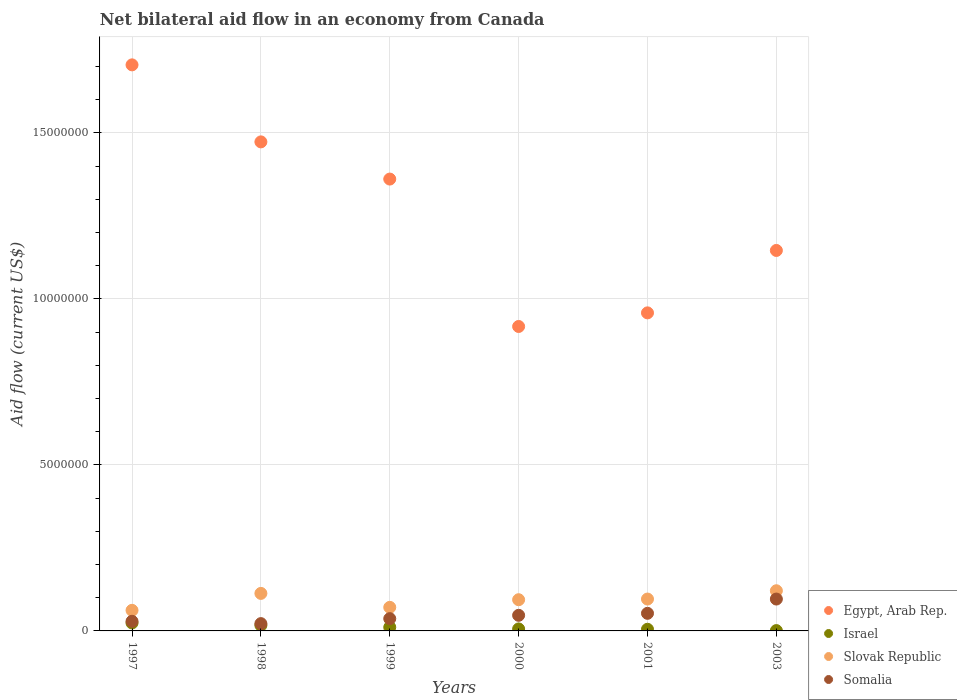Is the number of dotlines equal to the number of legend labels?
Ensure brevity in your answer.  Yes. What is the net bilateral aid flow in Somalia in 1998?
Offer a terse response. 2.20e+05. Across all years, what is the maximum net bilateral aid flow in Egypt, Arab Rep.?
Your response must be concise. 1.70e+07. Across all years, what is the minimum net bilateral aid flow in Egypt, Arab Rep.?
Make the answer very short. 9.17e+06. In which year was the net bilateral aid flow in Slovak Republic minimum?
Provide a succinct answer. 1997. What is the total net bilateral aid flow in Slovak Republic in the graph?
Provide a succinct answer. 5.57e+06. What is the difference between the net bilateral aid flow in Somalia in 1998 and that in 2003?
Provide a short and direct response. -7.40e+05. What is the difference between the net bilateral aid flow in Israel in 1998 and the net bilateral aid flow in Somalia in 1997?
Provide a succinct answer. -1.20e+05. What is the average net bilateral aid flow in Egypt, Arab Rep. per year?
Your answer should be very brief. 1.26e+07. In how many years, is the net bilateral aid flow in Egypt, Arab Rep. greater than 6000000 US$?
Offer a terse response. 6. What is the ratio of the net bilateral aid flow in Slovak Republic in 1997 to that in 2001?
Make the answer very short. 0.65. What is the difference between the highest and the lowest net bilateral aid flow in Egypt, Arab Rep.?
Your answer should be very brief. 7.88e+06. In how many years, is the net bilateral aid flow in Egypt, Arab Rep. greater than the average net bilateral aid flow in Egypt, Arab Rep. taken over all years?
Ensure brevity in your answer.  3. Is it the case that in every year, the sum of the net bilateral aid flow in Egypt, Arab Rep. and net bilateral aid flow in Somalia  is greater than the sum of net bilateral aid flow in Israel and net bilateral aid flow in Slovak Republic?
Offer a very short reply. Yes. Is it the case that in every year, the sum of the net bilateral aid flow in Slovak Republic and net bilateral aid flow in Somalia  is greater than the net bilateral aid flow in Israel?
Ensure brevity in your answer.  Yes. Does the net bilateral aid flow in Somalia monotonically increase over the years?
Make the answer very short. No. Is the net bilateral aid flow in Slovak Republic strictly greater than the net bilateral aid flow in Egypt, Arab Rep. over the years?
Provide a succinct answer. No. Are the values on the major ticks of Y-axis written in scientific E-notation?
Your answer should be very brief. No. Does the graph contain any zero values?
Provide a succinct answer. No. Does the graph contain grids?
Offer a very short reply. Yes. Where does the legend appear in the graph?
Offer a terse response. Bottom right. What is the title of the graph?
Provide a short and direct response. Net bilateral aid flow in an economy from Canada. Does "Macedonia" appear as one of the legend labels in the graph?
Your response must be concise. No. What is the label or title of the X-axis?
Offer a very short reply. Years. What is the Aid flow (current US$) of Egypt, Arab Rep. in 1997?
Give a very brief answer. 1.70e+07. What is the Aid flow (current US$) in Israel in 1997?
Keep it short and to the point. 2.40e+05. What is the Aid flow (current US$) of Slovak Republic in 1997?
Give a very brief answer. 6.20e+05. What is the Aid flow (current US$) in Somalia in 1997?
Ensure brevity in your answer.  2.90e+05. What is the Aid flow (current US$) in Egypt, Arab Rep. in 1998?
Provide a short and direct response. 1.47e+07. What is the Aid flow (current US$) in Slovak Republic in 1998?
Provide a short and direct response. 1.13e+06. What is the Aid flow (current US$) in Somalia in 1998?
Offer a terse response. 2.20e+05. What is the Aid flow (current US$) in Egypt, Arab Rep. in 1999?
Your answer should be very brief. 1.36e+07. What is the Aid flow (current US$) of Israel in 1999?
Provide a short and direct response. 1.10e+05. What is the Aid flow (current US$) of Slovak Republic in 1999?
Your answer should be compact. 7.10e+05. What is the Aid flow (current US$) of Egypt, Arab Rep. in 2000?
Keep it short and to the point. 9.17e+06. What is the Aid flow (current US$) in Israel in 2000?
Your answer should be very brief. 6.00e+04. What is the Aid flow (current US$) of Slovak Republic in 2000?
Provide a succinct answer. 9.40e+05. What is the Aid flow (current US$) of Egypt, Arab Rep. in 2001?
Provide a short and direct response. 9.58e+06. What is the Aid flow (current US$) of Israel in 2001?
Provide a succinct answer. 5.00e+04. What is the Aid flow (current US$) in Slovak Republic in 2001?
Give a very brief answer. 9.60e+05. What is the Aid flow (current US$) in Somalia in 2001?
Your answer should be very brief. 5.30e+05. What is the Aid flow (current US$) in Egypt, Arab Rep. in 2003?
Provide a succinct answer. 1.15e+07. What is the Aid flow (current US$) in Slovak Republic in 2003?
Provide a succinct answer. 1.21e+06. What is the Aid flow (current US$) of Somalia in 2003?
Keep it short and to the point. 9.60e+05. Across all years, what is the maximum Aid flow (current US$) of Egypt, Arab Rep.?
Keep it short and to the point. 1.70e+07. Across all years, what is the maximum Aid flow (current US$) of Slovak Republic?
Give a very brief answer. 1.21e+06. Across all years, what is the maximum Aid flow (current US$) in Somalia?
Give a very brief answer. 9.60e+05. Across all years, what is the minimum Aid flow (current US$) in Egypt, Arab Rep.?
Provide a succinct answer. 9.17e+06. Across all years, what is the minimum Aid flow (current US$) in Israel?
Your answer should be very brief. 10000. Across all years, what is the minimum Aid flow (current US$) in Slovak Republic?
Provide a succinct answer. 6.20e+05. Across all years, what is the minimum Aid flow (current US$) of Somalia?
Offer a terse response. 2.20e+05. What is the total Aid flow (current US$) of Egypt, Arab Rep. in the graph?
Give a very brief answer. 7.56e+07. What is the total Aid flow (current US$) of Israel in the graph?
Your answer should be compact. 6.40e+05. What is the total Aid flow (current US$) in Slovak Republic in the graph?
Ensure brevity in your answer.  5.57e+06. What is the total Aid flow (current US$) of Somalia in the graph?
Ensure brevity in your answer.  2.84e+06. What is the difference between the Aid flow (current US$) of Egypt, Arab Rep. in 1997 and that in 1998?
Your response must be concise. 2.32e+06. What is the difference between the Aid flow (current US$) in Slovak Republic in 1997 and that in 1998?
Keep it short and to the point. -5.10e+05. What is the difference between the Aid flow (current US$) in Egypt, Arab Rep. in 1997 and that in 1999?
Provide a short and direct response. 3.44e+06. What is the difference between the Aid flow (current US$) of Israel in 1997 and that in 1999?
Provide a succinct answer. 1.30e+05. What is the difference between the Aid flow (current US$) of Somalia in 1997 and that in 1999?
Make the answer very short. -8.00e+04. What is the difference between the Aid flow (current US$) of Egypt, Arab Rep. in 1997 and that in 2000?
Provide a short and direct response. 7.88e+06. What is the difference between the Aid flow (current US$) in Slovak Republic in 1997 and that in 2000?
Keep it short and to the point. -3.20e+05. What is the difference between the Aid flow (current US$) of Somalia in 1997 and that in 2000?
Keep it short and to the point. -1.80e+05. What is the difference between the Aid flow (current US$) in Egypt, Arab Rep. in 1997 and that in 2001?
Provide a short and direct response. 7.47e+06. What is the difference between the Aid flow (current US$) of Israel in 1997 and that in 2001?
Offer a very short reply. 1.90e+05. What is the difference between the Aid flow (current US$) in Somalia in 1997 and that in 2001?
Your response must be concise. -2.40e+05. What is the difference between the Aid flow (current US$) of Egypt, Arab Rep. in 1997 and that in 2003?
Make the answer very short. 5.59e+06. What is the difference between the Aid flow (current US$) in Israel in 1997 and that in 2003?
Provide a short and direct response. 2.30e+05. What is the difference between the Aid flow (current US$) in Slovak Republic in 1997 and that in 2003?
Your answer should be compact. -5.90e+05. What is the difference between the Aid flow (current US$) in Somalia in 1997 and that in 2003?
Offer a very short reply. -6.70e+05. What is the difference between the Aid flow (current US$) in Egypt, Arab Rep. in 1998 and that in 1999?
Your answer should be very brief. 1.12e+06. What is the difference between the Aid flow (current US$) in Egypt, Arab Rep. in 1998 and that in 2000?
Give a very brief answer. 5.56e+06. What is the difference between the Aid flow (current US$) of Egypt, Arab Rep. in 1998 and that in 2001?
Provide a succinct answer. 5.15e+06. What is the difference between the Aid flow (current US$) in Israel in 1998 and that in 2001?
Your response must be concise. 1.20e+05. What is the difference between the Aid flow (current US$) in Slovak Republic in 1998 and that in 2001?
Ensure brevity in your answer.  1.70e+05. What is the difference between the Aid flow (current US$) of Somalia in 1998 and that in 2001?
Ensure brevity in your answer.  -3.10e+05. What is the difference between the Aid flow (current US$) in Egypt, Arab Rep. in 1998 and that in 2003?
Offer a very short reply. 3.27e+06. What is the difference between the Aid flow (current US$) of Israel in 1998 and that in 2003?
Your answer should be compact. 1.60e+05. What is the difference between the Aid flow (current US$) of Slovak Republic in 1998 and that in 2003?
Provide a succinct answer. -8.00e+04. What is the difference between the Aid flow (current US$) in Somalia in 1998 and that in 2003?
Your answer should be very brief. -7.40e+05. What is the difference between the Aid flow (current US$) of Egypt, Arab Rep. in 1999 and that in 2000?
Make the answer very short. 4.44e+06. What is the difference between the Aid flow (current US$) of Israel in 1999 and that in 2000?
Keep it short and to the point. 5.00e+04. What is the difference between the Aid flow (current US$) of Slovak Republic in 1999 and that in 2000?
Offer a very short reply. -2.30e+05. What is the difference between the Aid flow (current US$) of Egypt, Arab Rep. in 1999 and that in 2001?
Keep it short and to the point. 4.03e+06. What is the difference between the Aid flow (current US$) in Egypt, Arab Rep. in 1999 and that in 2003?
Your answer should be compact. 2.15e+06. What is the difference between the Aid flow (current US$) in Slovak Republic in 1999 and that in 2003?
Keep it short and to the point. -5.00e+05. What is the difference between the Aid flow (current US$) of Somalia in 1999 and that in 2003?
Your answer should be very brief. -5.90e+05. What is the difference between the Aid flow (current US$) of Egypt, Arab Rep. in 2000 and that in 2001?
Keep it short and to the point. -4.10e+05. What is the difference between the Aid flow (current US$) in Slovak Republic in 2000 and that in 2001?
Your answer should be compact. -2.00e+04. What is the difference between the Aid flow (current US$) in Somalia in 2000 and that in 2001?
Provide a short and direct response. -6.00e+04. What is the difference between the Aid flow (current US$) of Egypt, Arab Rep. in 2000 and that in 2003?
Your response must be concise. -2.29e+06. What is the difference between the Aid flow (current US$) of Israel in 2000 and that in 2003?
Ensure brevity in your answer.  5.00e+04. What is the difference between the Aid flow (current US$) in Somalia in 2000 and that in 2003?
Ensure brevity in your answer.  -4.90e+05. What is the difference between the Aid flow (current US$) in Egypt, Arab Rep. in 2001 and that in 2003?
Make the answer very short. -1.88e+06. What is the difference between the Aid flow (current US$) of Somalia in 2001 and that in 2003?
Provide a short and direct response. -4.30e+05. What is the difference between the Aid flow (current US$) of Egypt, Arab Rep. in 1997 and the Aid flow (current US$) of Israel in 1998?
Keep it short and to the point. 1.69e+07. What is the difference between the Aid flow (current US$) of Egypt, Arab Rep. in 1997 and the Aid flow (current US$) of Slovak Republic in 1998?
Offer a terse response. 1.59e+07. What is the difference between the Aid flow (current US$) in Egypt, Arab Rep. in 1997 and the Aid flow (current US$) in Somalia in 1998?
Provide a short and direct response. 1.68e+07. What is the difference between the Aid flow (current US$) of Israel in 1997 and the Aid flow (current US$) of Slovak Republic in 1998?
Provide a short and direct response. -8.90e+05. What is the difference between the Aid flow (current US$) in Egypt, Arab Rep. in 1997 and the Aid flow (current US$) in Israel in 1999?
Ensure brevity in your answer.  1.69e+07. What is the difference between the Aid flow (current US$) in Egypt, Arab Rep. in 1997 and the Aid flow (current US$) in Slovak Republic in 1999?
Make the answer very short. 1.63e+07. What is the difference between the Aid flow (current US$) in Egypt, Arab Rep. in 1997 and the Aid flow (current US$) in Somalia in 1999?
Ensure brevity in your answer.  1.67e+07. What is the difference between the Aid flow (current US$) of Israel in 1997 and the Aid flow (current US$) of Slovak Republic in 1999?
Give a very brief answer. -4.70e+05. What is the difference between the Aid flow (current US$) of Israel in 1997 and the Aid flow (current US$) of Somalia in 1999?
Provide a succinct answer. -1.30e+05. What is the difference between the Aid flow (current US$) in Slovak Republic in 1997 and the Aid flow (current US$) in Somalia in 1999?
Provide a succinct answer. 2.50e+05. What is the difference between the Aid flow (current US$) of Egypt, Arab Rep. in 1997 and the Aid flow (current US$) of Israel in 2000?
Your response must be concise. 1.70e+07. What is the difference between the Aid flow (current US$) of Egypt, Arab Rep. in 1997 and the Aid flow (current US$) of Slovak Republic in 2000?
Your answer should be compact. 1.61e+07. What is the difference between the Aid flow (current US$) of Egypt, Arab Rep. in 1997 and the Aid flow (current US$) of Somalia in 2000?
Keep it short and to the point. 1.66e+07. What is the difference between the Aid flow (current US$) of Israel in 1997 and the Aid flow (current US$) of Slovak Republic in 2000?
Provide a succinct answer. -7.00e+05. What is the difference between the Aid flow (current US$) in Egypt, Arab Rep. in 1997 and the Aid flow (current US$) in Israel in 2001?
Offer a very short reply. 1.70e+07. What is the difference between the Aid flow (current US$) of Egypt, Arab Rep. in 1997 and the Aid flow (current US$) of Slovak Republic in 2001?
Provide a short and direct response. 1.61e+07. What is the difference between the Aid flow (current US$) in Egypt, Arab Rep. in 1997 and the Aid flow (current US$) in Somalia in 2001?
Make the answer very short. 1.65e+07. What is the difference between the Aid flow (current US$) in Israel in 1997 and the Aid flow (current US$) in Slovak Republic in 2001?
Your response must be concise. -7.20e+05. What is the difference between the Aid flow (current US$) of Egypt, Arab Rep. in 1997 and the Aid flow (current US$) of Israel in 2003?
Offer a very short reply. 1.70e+07. What is the difference between the Aid flow (current US$) in Egypt, Arab Rep. in 1997 and the Aid flow (current US$) in Slovak Republic in 2003?
Offer a very short reply. 1.58e+07. What is the difference between the Aid flow (current US$) of Egypt, Arab Rep. in 1997 and the Aid flow (current US$) of Somalia in 2003?
Provide a succinct answer. 1.61e+07. What is the difference between the Aid flow (current US$) of Israel in 1997 and the Aid flow (current US$) of Slovak Republic in 2003?
Provide a short and direct response. -9.70e+05. What is the difference between the Aid flow (current US$) of Israel in 1997 and the Aid flow (current US$) of Somalia in 2003?
Provide a succinct answer. -7.20e+05. What is the difference between the Aid flow (current US$) in Slovak Republic in 1997 and the Aid flow (current US$) in Somalia in 2003?
Offer a very short reply. -3.40e+05. What is the difference between the Aid flow (current US$) in Egypt, Arab Rep. in 1998 and the Aid flow (current US$) in Israel in 1999?
Your answer should be compact. 1.46e+07. What is the difference between the Aid flow (current US$) in Egypt, Arab Rep. in 1998 and the Aid flow (current US$) in Slovak Republic in 1999?
Provide a short and direct response. 1.40e+07. What is the difference between the Aid flow (current US$) of Egypt, Arab Rep. in 1998 and the Aid flow (current US$) of Somalia in 1999?
Make the answer very short. 1.44e+07. What is the difference between the Aid flow (current US$) of Israel in 1998 and the Aid flow (current US$) of Slovak Republic in 1999?
Ensure brevity in your answer.  -5.40e+05. What is the difference between the Aid flow (current US$) in Israel in 1998 and the Aid flow (current US$) in Somalia in 1999?
Make the answer very short. -2.00e+05. What is the difference between the Aid flow (current US$) in Slovak Republic in 1998 and the Aid flow (current US$) in Somalia in 1999?
Your answer should be compact. 7.60e+05. What is the difference between the Aid flow (current US$) of Egypt, Arab Rep. in 1998 and the Aid flow (current US$) of Israel in 2000?
Ensure brevity in your answer.  1.47e+07. What is the difference between the Aid flow (current US$) in Egypt, Arab Rep. in 1998 and the Aid flow (current US$) in Slovak Republic in 2000?
Provide a succinct answer. 1.38e+07. What is the difference between the Aid flow (current US$) in Egypt, Arab Rep. in 1998 and the Aid flow (current US$) in Somalia in 2000?
Provide a short and direct response. 1.43e+07. What is the difference between the Aid flow (current US$) of Israel in 1998 and the Aid flow (current US$) of Slovak Republic in 2000?
Provide a short and direct response. -7.70e+05. What is the difference between the Aid flow (current US$) of Israel in 1998 and the Aid flow (current US$) of Somalia in 2000?
Your response must be concise. -3.00e+05. What is the difference between the Aid flow (current US$) in Slovak Republic in 1998 and the Aid flow (current US$) in Somalia in 2000?
Ensure brevity in your answer.  6.60e+05. What is the difference between the Aid flow (current US$) of Egypt, Arab Rep. in 1998 and the Aid flow (current US$) of Israel in 2001?
Ensure brevity in your answer.  1.47e+07. What is the difference between the Aid flow (current US$) in Egypt, Arab Rep. in 1998 and the Aid flow (current US$) in Slovak Republic in 2001?
Your answer should be very brief. 1.38e+07. What is the difference between the Aid flow (current US$) in Egypt, Arab Rep. in 1998 and the Aid flow (current US$) in Somalia in 2001?
Your response must be concise. 1.42e+07. What is the difference between the Aid flow (current US$) in Israel in 1998 and the Aid flow (current US$) in Slovak Republic in 2001?
Offer a very short reply. -7.90e+05. What is the difference between the Aid flow (current US$) in Israel in 1998 and the Aid flow (current US$) in Somalia in 2001?
Give a very brief answer. -3.60e+05. What is the difference between the Aid flow (current US$) of Slovak Republic in 1998 and the Aid flow (current US$) of Somalia in 2001?
Offer a terse response. 6.00e+05. What is the difference between the Aid flow (current US$) in Egypt, Arab Rep. in 1998 and the Aid flow (current US$) in Israel in 2003?
Your response must be concise. 1.47e+07. What is the difference between the Aid flow (current US$) in Egypt, Arab Rep. in 1998 and the Aid flow (current US$) in Slovak Republic in 2003?
Provide a short and direct response. 1.35e+07. What is the difference between the Aid flow (current US$) of Egypt, Arab Rep. in 1998 and the Aid flow (current US$) of Somalia in 2003?
Keep it short and to the point. 1.38e+07. What is the difference between the Aid flow (current US$) of Israel in 1998 and the Aid flow (current US$) of Slovak Republic in 2003?
Ensure brevity in your answer.  -1.04e+06. What is the difference between the Aid flow (current US$) of Israel in 1998 and the Aid flow (current US$) of Somalia in 2003?
Ensure brevity in your answer.  -7.90e+05. What is the difference between the Aid flow (current US$) in Egypt, Arab Rep. in 1999 and the Aid flow (current US$) in Israel in 2000?
Ensure brevity in your answer.  1.36e+07. What is the difference between the Aid flow (current US$) in Egypt, Arab Rep. in 1999 and the Aid flow (current US$) in Slovak Republic in 2000?
Give a very brief answer. 1.27e+07. What is the difference between the Aid flow (current US$) in Egypt, Arab Rep. in 1999 and the Aid flow (current US$) in Somalia in 2000?
Give a very brief answer. 1.31e+07. What is the difference between the Aid flow (current US$) in Israel in 1999 and the Aid flow (current US$) in Slovak Republic in 2000?
Keep it short and to the point. -8.30e+05. What is the difference between the Aid flow (current US$) in Israel in 1999 and the Aid flow (current US$) in Somalia in 2000?
Keep it short and to the point. -3.60e+05. What is the difference between the Aid flow (current US$) of Egypt, Arab Rep. in 1999 and the Aid flow (current US$) of Israel in 2001?
Your response must be concise. 1.36e+07. What is the difference between the Aid flow (current US$) in Egypt, Arab Rep. in 1999 and the Aid flow (current US$) in Slovak Republic in 2001?
Your answer should be very brief. 1.26e+07. What is the difference between the Aid flow (current US$) of Egypt, Arab Rep. in 1999 and the Aid flow (current US$) of Somalia in 2001?
Your response must be concise. 1.31e+07. What is the difference between the Aid flow (current US$) of Israel in 1999 and the Aid flow (current US$) of Slovak Republic in 2001?
Ensure brevity in your answer.  -8.50e+05. What is the difference between the Aid flow (current US$) in Israel in 1999 and the Aid flow (current US$) in Somalia in 2001?
Make the answer very short. -4.20e+05. What is the difference between the Aid flow (current US$) of Slovak Republic in 1999 and the Aid flow (current US$) of Somalia in 2001?
Provide a short and direct response. 1.80e+05. What is the difference between the Aid flow (current US$) of Egypt, Arab Rep. in 1999 and the Aid flow (current US$) of Israel in 2003?
Offer a very short reply. 1.36e+07. What is the difference between the Aid flow (current US$) in Egypt, Arab Rep. in 1999 and the Aid flow (current US$) in Slovak Republic in 2003?
Provide a succinct answer. 1.24e+07. What is the difference between the Aid flow (current US$) of Egypt, Arab Rep. in 1999 and the Aid flow (current US$) of Somalia in 2003?
Ensure brevity in your answer.  1.26e+07. What is the difference between the Aid flow (current US$) of Israel in 1999 and the Aid flow (current US$) of Slovak Republic in 2003?
Offer a very short reply. -1.10e+06. What is the difference between the Aid flow (current US$) of Israel in 1999 and the Aid flow (current US$) of Somalia in 2003?
Your response must be concise. -8.50e+05. What is the difference between the Aid flow (current US$) in Egypt, Arab Rep. in 2000 and the Aid flow (current US$) in Israel in 2001?
Your response must be concise. 9.12e+06. What is the difference between the Aid flow (current US$) of Egypt, Arab Rep. in 2000 and the Aid flow (current US$) of Slovak Republic in 2001?
Your response must be concise. 8.21e+06. What is the difference between the Aid flow (current US$) of Egypt, Arab Rep. in 2000 and the Aid flow (current US$) of Somalia in 2001?
Make the answer very short. 8.64e+06. What is the difference between the Aid flow (current US$) of Israel in 2000 and the Aid flow (current US$) of Slovak Republic in 2001?
Offer a terse response. -9.00e+05. What is the difference between the Aid flow (current US$) of Israel in 2000 and the Aid flow (current US$) of Somalia in 2001?
Offer a terse response. -4.70e+05. What is the difference between the Aid flow (current US$) of Slovak Republic in 2000 and the Aid flow (current US$) of Somalia in 2001?
Your answer should be very brief. 4.10e+05. What is the difference between the Aid flow (current US$) in Egypt, Arab Rep. in 2000 and the Aid flow (current US$) in Israel in 2003?
Give a very brief answer. 9.16e+06. What is the difference between the Aid flow (current US$) in Egypt, Arab Rep. in 2000 and the Aid flow (current US$) in Slovak Republic in 2003?
Provide a succinct answer. 7.96e+06. What is the difference between the Aid flow (current US$) of Egypt, Arab Rep. in 2000 and the Aid flow (current US$) of Somalia in 2003?
Make the answer very short. 8.21e+06. What is the difference between the Aid flow (current US$) of Israel in 2000 and the Aid flow (current US$) of Slovak Republic in 2003?
Your answer should be very brief. -1.15e+06. What is the difference between the Aid flow (current US$) in Israel in 2000 and the Aid flow (current US$) in Somalia in 2003?
Make the answer very short. -9.00e+05. What is the difference between the Aid flow (current US$) in Egypt, Arab Rep. in 2001 and the Aid flow (current US$) in Israel in 2003?
Offer a very short reply. 9.57e+06. What is the difference between the Aid flow (current US$) of Egypt, Arab Rep. in 2001 and the Aid flow (current US$) of Slovak Republic in 2003?
Your answer should be very brief. 8.37e+06. What is the difference between the Aid flow (current US$) in Egypt, Arab Rep. in 2001 and the Aid flow (current US$) in Somalia in 2003?
Keep it short and to the point. 8.62e+06. What is the difference between the Aid flow (current US$) of Israel in 2001 and the Aid flow (current US$) of Slovak Republic in 2003?
Provide a short and direct response. -1.16e+06. What is the difference between the Aid flow (current US$) of Israel in 2001 and the Aid flow (current US$) of Somalia in 2003?
Your response must be concise. -9.10e+05. What is the difference between the Aid flow (current US$) in Slovak Republic in 2001 and the Aid flow (current US$) in Somalia in 2003?
Offer a terse response. 0. What is the average Aid flow (current US$) in Egypt, Arab Rep. per year?
Your answer should be very brief. 1.26e+07. What is the average Aid flow (current US$) of Israel per year?
Offer a terse response. 1.07e+05. What is the average Aid flow (current US$) in Slovak Republic per year?
Your answer should be very brief. 9.28e+05. What is the average Aid flow (current US$) in Somalia per year?
Keep it short and to the point. 4.73e+05. In the year 1997, what is the difference between the Aid flow (current US$) of Egypt, Arab Rep. and Aid flow (current US$) of Israel?
Your answer should be compact. 1.68e+07. In the year 1997, what is the difference between the Aid flow (current US$) of Egypt, Arab Rep. and Aid flow (current US$) of Slovak Republic?
Your answer should be compact. 1.64e+07. In the year 1997, what is the difference between the Aid flow (current US$) of Egypt, Arab Rep. and Aid flow (current US$) of Somalia?
Provide a short and direct response. 1.68e+07. In the year 1997, what is the difference between the Aid flow (current US$) in Israel and Aid flow (current US$) in Slovak Republic?
Give a very brief answer. -3.80e+05. In the year 1997, what is the difference between the Aid flow (current US$) of Israel and Aid flow (current US$) of Somalia?
Give a very brief answer. -5.00e+04. In the year 1998, what is the difference between the Aid flow (current US$) in Egypt, Arab Rep. and Aid flow (current US$) in Israel?
Provide a succinct answer. 1.46e+07. In the year 1998, what is the difference between the Aid flow (current US$) in Egypt, Arab Rep. and Aid flow (current US$) in Slovak Republic?
Provide a succinct answer. 1.36e+07. In the year 1998, what is the difference between the Aid flow (current US$) in Egypt, Arab Rep. and Aid flow (current US$) in Somalia?
Your response must be concise. 1.45e+07. In the year 1998, what is the difference between the Aid flow (current US$) of Israel and Aid flow (current US$) of Slovak Republic?
Your response must be concise. -9.60e+05. In the year 1998, what is the difference between the Aid flow (current US$) in Slovak Republic and Aid flow (current US$) in Somalia?
Keep it short and to the point. 9.10e+05. In the year 1999, what is the difference between the Aid flow (current US$) in Egypt, Arab Rep. and Aid flow (current US$) in Israel?
Make the answer very short. 1.35e+07. In the year 1999, what is the difference between the Aid flow (current US$) of Egypt, Arab Rep. and Aid flow (current US$) of Slovak Republic?
Provide a short and direct response. 1.29e+07. In the year 1999, what is the difference between the Aid flow (current US$) in Egypt, Arab Rep. and Aid flow (current US$) in Somalia?
Provide a succinct answer. 1.32e+07. In the year 1999, what is the difference between the Aid flow (current US$) of Israel and Aid flow (current US$) of Slovak Republic?
Make the answer very short. -6.00e+05. In the year 2000, what is the difference between the Aid flow (current US$) of Egypt, Arab Rep. and Aid flow (current US$) of Israel?
Your answer should be very brief. 9.11e+06. In the year 2000, what is the difference between the Aid flow (current US$) of Egypt, Arab Rep. and Aid flow (current US$) of Slovak Republic?
Ensure brevity in your answer.  8.23e+06. In the year 2000, what is the difference between the Aid flow (current US$) in Egypt, Arab Rep. and Aid flow (current US$) in Somalia?
Provide a short and direct response. 8.70e+06. In the year 2000, what is the difference between the Aid flow (current US$) of Israel and Aid flow (current US$) of Slovak Republic?
Your answer should be compact. -8.80e+05. In the year 2000, what is the difference between the Aid flow (current US$) in Israel and Aid flow (current US$) in Somalia?
Your answer should be very brief. -4.10e+05. In the year 2000, what is the difference between the Aid flow (current US$) in Slovak Republic and Aid flow (current US$) in Somalia?
Your response must be concise. 4.70e+05. In the year 2001, what is the difference between the Aid flow (current US$) in Egypt, Arab Rep. and Aid flow (current US$) in Israel?
Your response must be concise. 9.53e+06. In the year 2001, what is the difference between the Aid flow (current US$) in Egypt, Arab Rep. and Aid flow (current US$) in Slovak Republic?
Make the answer very short. 8.62e+06. In the year 2001, what is the difference between the Aid flow (current US$) of Egypt, Arab Rep. and Aid flow (current US$) of Somalia?
Make the answer very short. 9.05e+06. In the year 2001, what is the difference between the Aid flow (current US$) of Israel and Aid flow (current US$) of Slovak Republic?
Offer a terse response. -9.10e+05. In the year 2001, what is the difference between the Aid flow (current US$) in Israel and Aid flow (current US$) in Somalia?
Provide a short and direct response. -4.80e+05. In the year 2003, what is the difference between the Aid flow (current US$) in Egypt, Arab Rep. and Aid flow (current US$) in Israel?
Provide a short and direct response. 1.14e+07. In the year 2003, what is the difference between the Aid flow (current US$) of Egypt, Arab Rep. and Aid flow (current US$) of Slovak Republic?
Keep it short and to the point. 1.02e+07. In the year 2003, what is the difference between the Aid flow (current US$) of Egypt, Arab Rep. and Aid flow (current US$) of Somalia?
Provide a succinct answer. 1.05e+07. In the year 2003, what is the difference between the Aid flow (current US$) of Israel and Aid flow (current US$) of Slovak Republic?
Make the answer very short. -1.20e+06. In the year 2003, what is the difference between the Aid flow (current US$) of Israel and Aid flow (current US$) of Somalia?
Give a very brief answer. -9.50e+05. What is the ratio of the Aid flow (current US$) of Egypt, Arab Rep. in 1997 to that in 1998?
Offer a very short reply. 1.16. What is the ratio of the Aid flow (current US$) in Israel in 1997 to that in 1998?
Offer a terse response. 1.41. What is the ratio of the Aid flow (current US$) in Slovak Republic in 1997 to that in 1998?
Keep it short and to the point. 0.55. What is the ratio of the Aid flow (current US$) in Somalia in 1997 to that in 1998?
Offer a terse response. 1.32. What is the ratio of the Aid flow (current US$) in Egypt, Arab Rep. in 1997 to that in 1999?
Ensure brevity in your answer.  1.25. What is the ratio of the Aid flow (current US$) in Israel in 1997 to that in 1999?
Your answer should be compact. 2.18. What is the ratio of the Aid flow (current US$) of Slovak Republic in 1997 to that in 1999?
Make the answer very short. 0.87. What is the ratio of the Aid flow (current US$) in Somalia in 1997 to that in 1999?
Offer a terse response. 0.78. What is the ratio of the Aid flow (current US$) in Egypt, Arab Rep. in 1997 to that in 2000?
Offer a terse response. 1.86. What is the ratio of the Aid flow (current US$) of Israel in 1997 to that in 2000?
Provide a succinct answer. 4. What is the ratio of the Aid flow (current US$) of Slovak Republic in 1997 to that in 2000?
Provide a short and direct response. 0.66. What is the ratio of the Aid flow (current US$) of Somalia in 1997 to that in 2000?
Provide a short and direct response. 0.62. What is the ratio of the Aid flow (current US$) in Egypt, Arab Rep. in 1997 to that in 2001?
Ensure brevity in your answer.  1.78. What is the ratio of the Aid flow (current US$) in Slovak Republic in 1997 to that in 2001?
Keep it short and to the point. 0.65. What is the ratio of the Aid flow (current US$) of Somalia in 1997 to that in 2001?
Your answer should be very brief. 0.55. What is the ratio of the Aid flow (current US$) of Egypt, Arab Rep. in 1997 to that in 2003?
Your answer should be compact. 1.49. What is the ratio of the Aid flow (current US$) of Slovak Republic in 1997 to that in 2003?
Provide a short and direct response. 0.51. What is the ratio of the Aid flow (current US$) of Somalia in 1997 to that in 2003?
Provide a short and direct response. 0.3. What is the ratio of the Aid flow (current US$) in Egypt, Arab Rep. in 1998 to that in 1999?
Offer a very short reply. 1.08. What is the ratio of the Aid flow (current US$) in Israel in 1998 to that in 1999?
Ensure brevity in your answer.  1.55. What is the ratio of the Aid flow (current US$) in Slovak Republic in 1998 to that in 1999?
Offer a terse response. 1.59. What is the ratio of the Aid flow (current US$) in Somalia in 1998 to that in 1999?
Your answer should be very brief. 0.59. What is the ratio of the Aid flow (current US$) of Egypt, Arab Rep. in 1998 to that in 2000?
Your response must be concise. 1.61. What is the ratio of the Aid flow (current US$) of Israel in 1998 to that in 2000?
Give a very brief answer. 2.83. What is the ratio of the Aid flow (current US$) of Slovak Republic in 1998 to that in 2000?
Your response must be concise. 1.2. What is the ratio of the Aid flow (current US$) in Somalia in 1998 to that in 2000?
Offer a terse response. 0.47. What is the ratio of the Aid flow (current US$) of Egypt, Arab Rep. in 1998 to that in 2001?
Keep it short and to the point. 1.54. What is the ratio of the Aid flow (current US$) in Israel in 1998 to that in 2001?
Provide a short and direct response. 3.4. What is the ratio of the Aid flow (current US$) of Slovak Republic in 1998 to that in 2001?
Your response must be concise. 1.18. What is the ratio of the Aid flow (current US$) of Somalia in 1998 to that in 2001?
Your response must be concise. 0.42. What is the ratio of the Aid flow (current US$) in Egypt, Arab Rep. in 1998 to that in 2003?
Your response must be concise. 1.29. What is the ratio of the Aid flow (current US$) in Israel in 1998 to that in 2003?
Your answer should be very brief. 17. What is the ratio of the Aid flow (current US$) in Slovak Republic in 1998 to that in 2003?
Keep it short and to the point. 0.93. What is the ratio of the Aid flow (current US$) in Somalia in 1998 to that in 2003?
Give a very brief answer. 0.23. What is the ratio of the Aid flow (current US$) in Egypt, Arab Rep. in 1999 to that in 2000?
Give a very brief answer. 1.48. What is the ratio of the Aid flow (current US$) in Israel in 1999 to that in 2000?
Keep it short and to the point. 1.83. What is the ratio of the Aid flow (current US$) of Slovak Republic in 1999 to that in 2000?
Your answer should be compact. 0.76. What is the ratio of the Aid flow (current US$) of Somalia in 1999 to that in 2000?
Offer a terse response. 0.79. What is the ratio of the Aid flow (current US$) of Egypt, Arab Rep. in 1999 to that in 2001?
Offer a terse response. 1.42. What is the ratio of the Aid flow (current US$) in Slovak Republic in 1999 to that in 2001?
Give a very brief answer. 0.74. What is the ratio of the Aid flow (current US$) in Somalia in 1999 to that in 2001?
Provide a short and direct response. 0.7. What is the ratio of the Aid flow (current US$) of Egypt, Arab Rep. in 1999 to that in 2003?
Your response must be concise. 1.19. What is the ratio of the Aid flow (current US$) in Slovak Republic in 1999 to that in 2003?
Provide a short and direct response. 0.59. What is the ratio of the Aid flow (current US$) in Somalia in 1999 to that in 2003?
Your answer should be compact. 0.39. What is the ratio of the Aid flow (current US$) of Egypt, Arab Rep. in 2000 to that in 2001?
Ensure brevity in your answer.  0.96. What is the ratio of the Aid flow (current US$) of Slovak Republic in 2000 to that in 2001?
Provide a succinct answer. 0.98. What is the ratio of the Aid flow (current US$) of Somalia in 2000 to that in 2001?
Provide a short and direct response. 0.89. What is the ratio of the Aid flow (current US$) in Egypt, Arab Rep. in 2000 to that in 2003?
Offer a terse response. 0.8. What is the ratio of the Aid flow (current US$) in Israel in 2000 to that in 2003?
Provide a succinct answer. 6. What is the ratio of the Aid flow (current US$) in Slovak Republic in 2000 to that in 2003?
Make the answer very short. 0.78. What is the ratio of the Aid flow (current US$) of Somalia in 2000 to that in 2003?
Provide a succinct answer. 0.49. What is the ratio of the Aid flow (current US$) of Egypt, Arab Rep. in 2001 to that in 2003?
Offer a very short reply. 0.84. What is the ratio of the Aid flow (current US$) in Israel in 2001 to that in 2003?
Offer a terse response. 5. What is the ratio of the Aid flow (current US$) of Slovak Republic in 2001 to that in 2003?
Your response must be concise. 0.79. What is the ratio of the Aid flow (current US$) of Somalia in 2001 to that in 2003?
Your answer should be compact. 0.55. What is the difference between the highest and the second highest Aid flow (current US$) in Egypt, Arab Rep.?
Your answer should be very brief. 2.32e+06. What is the difference between the highest and the lowest Aid flow (current US$) of Egypt, Arab Rep.?
Your answer should be compact. 7.88e+06. What is the difference between the highest and the lowest Aid flow (current US$) in Israel?
Your answer should be very brief. 2.30e+05. What is the difference between the highest and the lowest Aid flow (current US$) in Slovak Republic?
Keep it short and to the point. 5.90e+05. What is the difference between the highest and the lowest Aid flow (current US$) of Somalia?
Make the answer very short. 7.40e+05. 